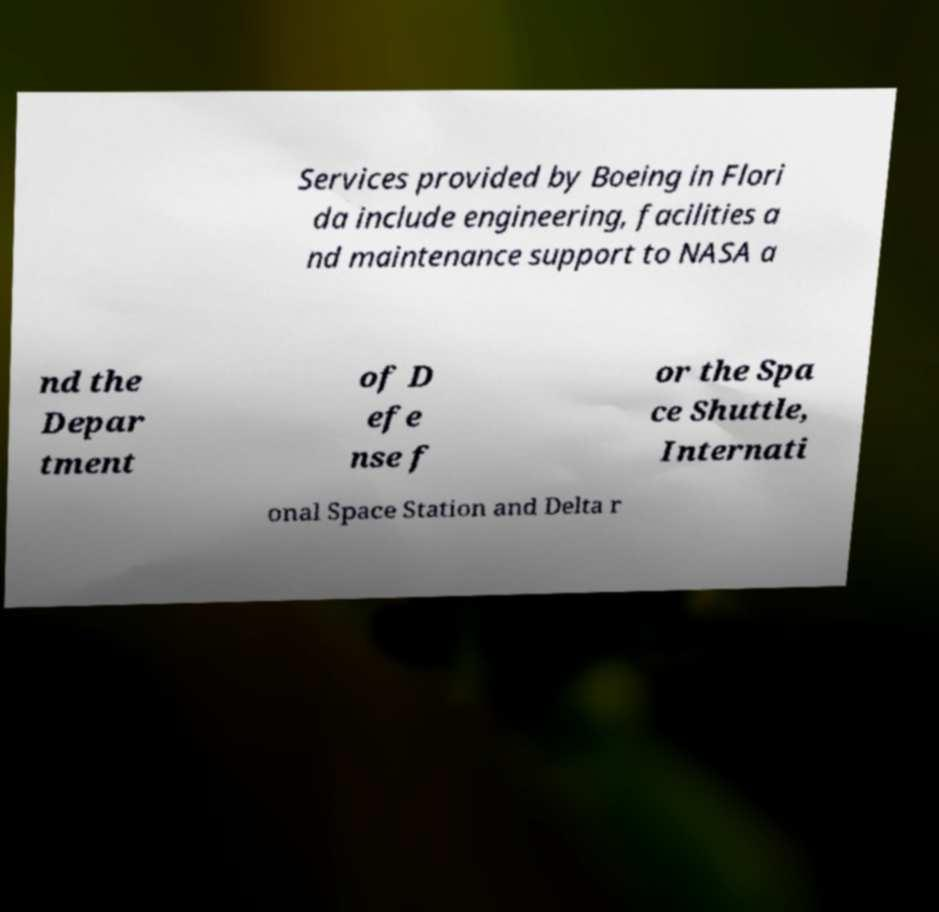Could you assist in decoding the text presented in this image and type it out clearly? Services provided by Boeing in Flori da include engineering, facilities a nd maintenance support to NASA a nd the Depar tment of D efe nse f or the Spa ce Shuttle, Internati onal Space Station and Delta r 